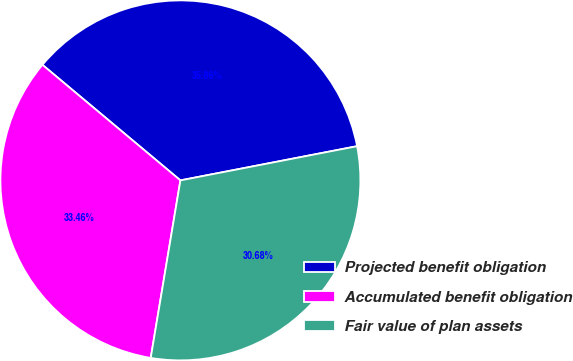Convert chart. <chart><loc_0><loc_0><loc_500><loc_500><pie_chart><fcel>Projected benefit obligation<fcel>Accumulated benefit obligation<fcel>Fair value of plan assets<nl><fcel>35.86%<fcel>33.46%<fcel>30.68%<nl></chart> 